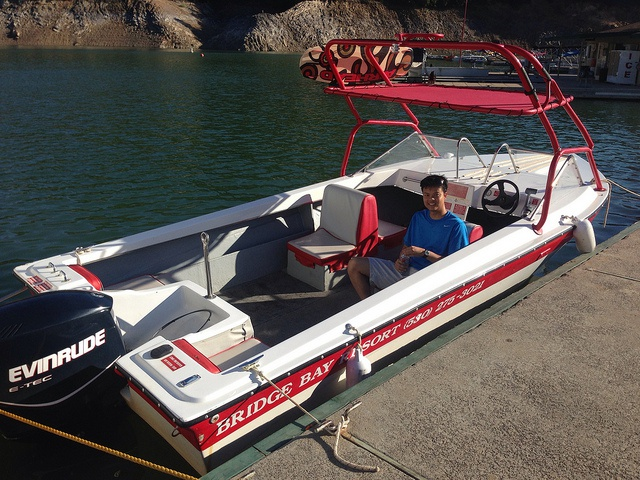Describe the objects in this image and their specific colors. I can see boat in black, lightgray, gray, and maroon tones, people in black, navy, maroon, and gray tones, and surfboard in black, maroon, and brown tones in this image. 